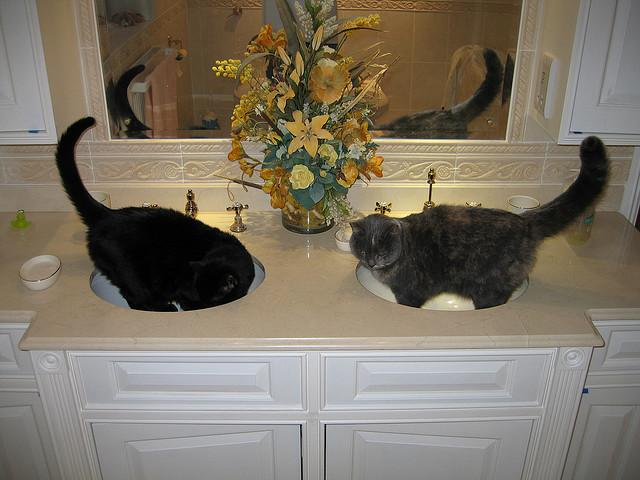Where are the cats playing? Please explain your reasoning. sink. The cats are each in sinks. 